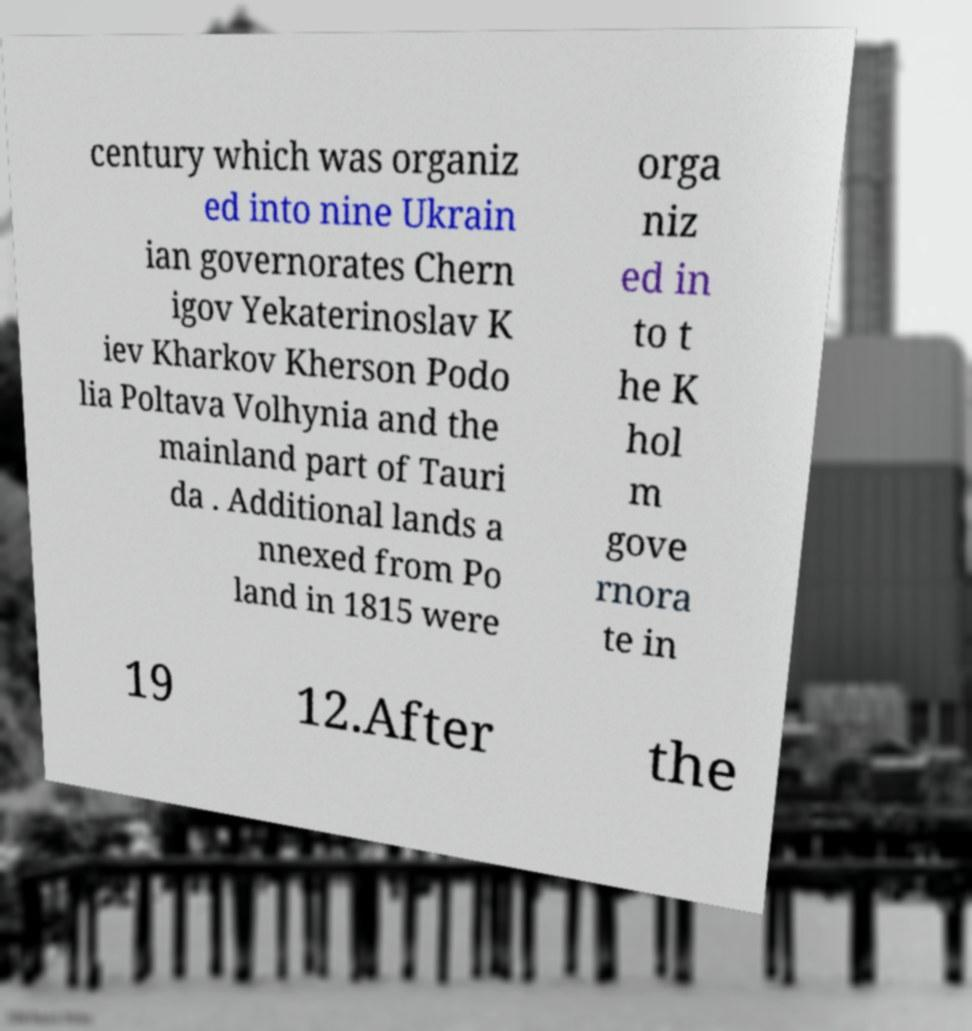Can you accurately transcribe the text from the provided image for me? century which was organiz ed into nine Ukrain ian governorates Chern igov Yekaterinoslav K iev Kharkov Kherson Podo lia Poltava Volhynia and the mainland part of Tauri da . Additional lands a nnexed from Po land in 1815 were orga niz ed in to t he K hol m gove rnora te in 19 12.After the 